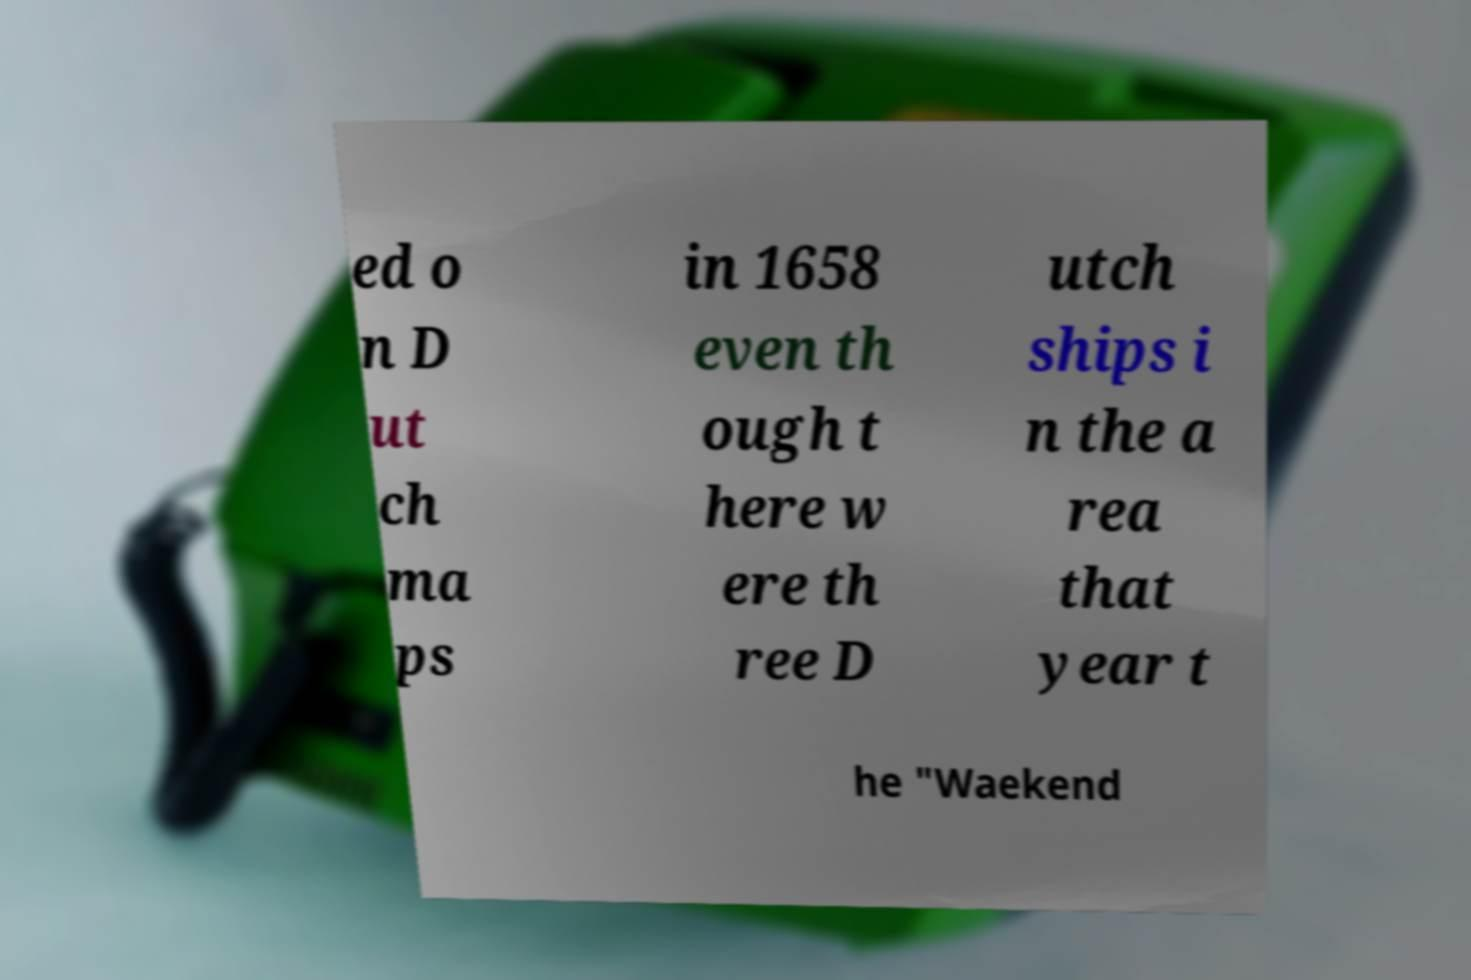What messages or text are displayed in this image? I need them in a readable, typed format. ed o n D ut ch ma ps in 1658 even th ough t here w ere th ree D utch ships i n the a rea that year t he "Waekend 